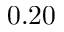Convert formula to latex. <formula><loc_0><loc_0><loc_500><loc_500>0 . 2 0</formula> 